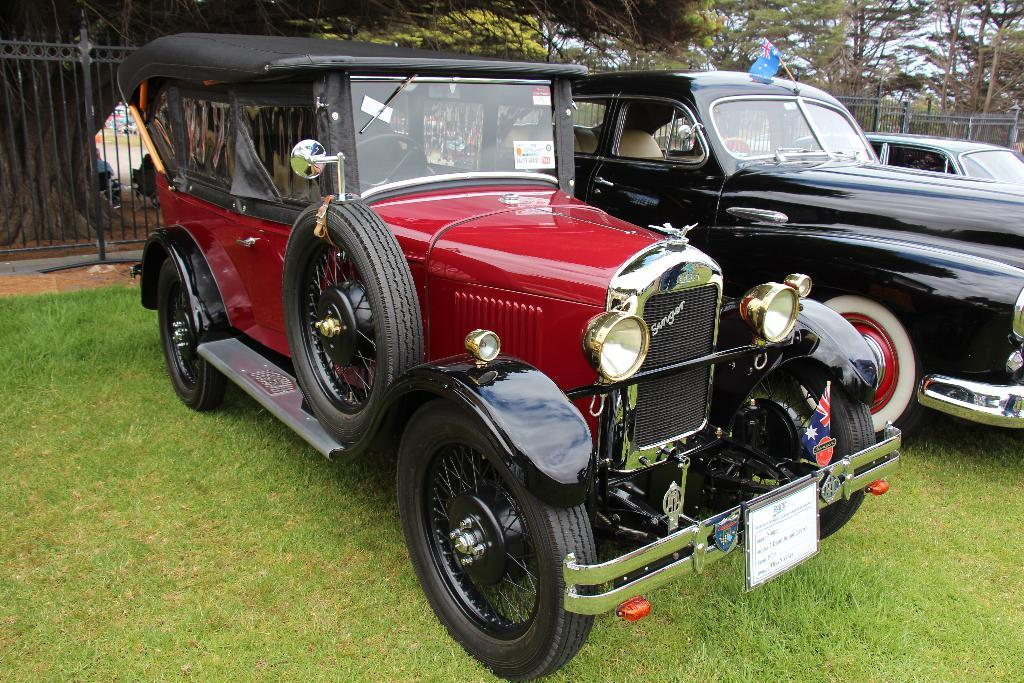What is the location of the parked vehicles in the image? The vehicles are parked in the grass in the image. What type of barrier can be seen in the image? There is a fence in the image. What is the symbolic object visible in the image? There is a flag in the image. What type of vegetation is present in the image? There are trees in the image. Can you see a quill being used to write a message on the flag in the image? There is no quill or writing activity present in the image. How many roses are visible on the trees in the image? There are no roses visible on the trees in the image; only the trees themselves are present. 